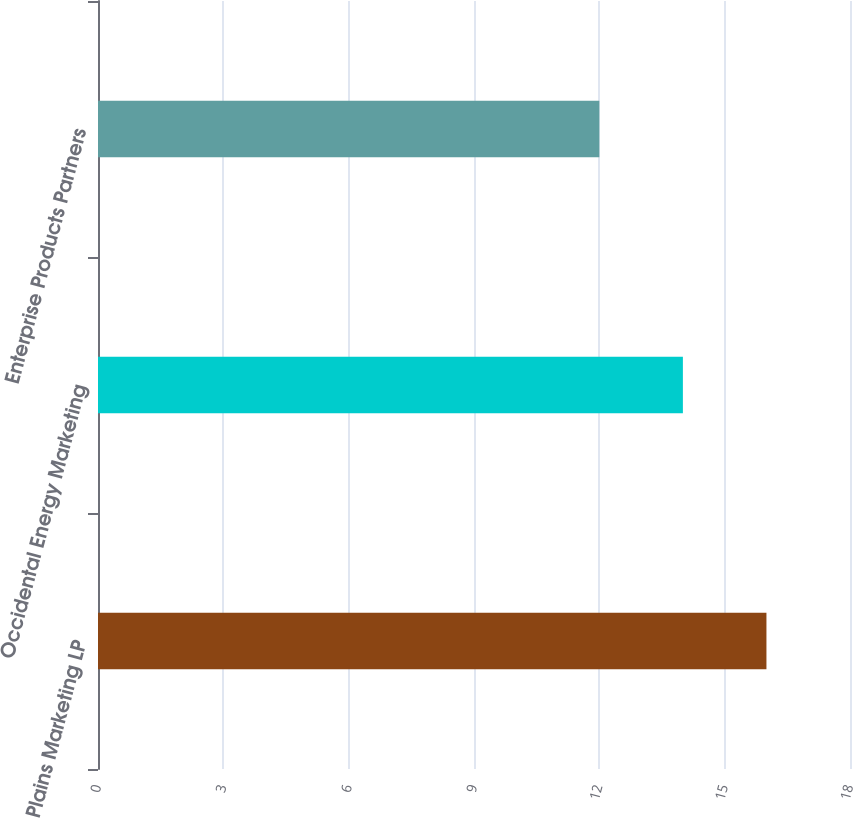Convert chart. <chart><loc_0><loc_0><loc_500><loc_500><bar_chart><fcel>Plains Marketing LP<fcel>Occidental Energy Marketing<fcel>Enterprise Products Partners<nl><fcel>16<fcel>14<fcel>12<nl></chart> 